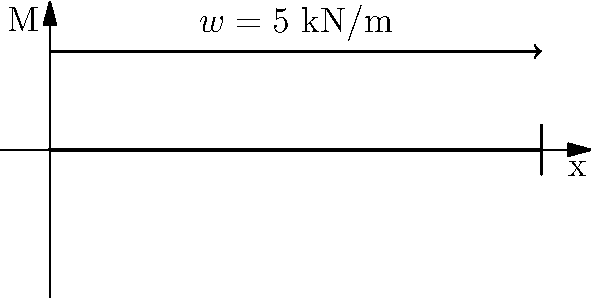A simply supported beam of length 10 m is subjected to a uniformly distributed load of 5 kN/m along its entire length. Calculate the maximum bending moment in the beam and sketch the bending moment diagram. To solve this problem, let's follow these steps:

1) First, we need to calculate the reactions at the supports:
   Total load = $5 \text{ kN/m} \times 10 \text{ m} = 50 \text{ kN}$
   Due to symmetry, each support reaction will be half of this:
   $R_A = R_B = 50 \text{ kN} / 2 = 25 \text{ kN}$

2) The maximum bending moment occurs at the center of the beam. We can calculate this using the formula:
   $M_{max} = \frac{wL^2}{8}$
   Where $w$ is the distributed load and $L$ is the length of the beam.

3) Substituting the values:
   $M_{max} = \frac{5 \text{ kN/m} \times (10 \text{ m})^2}{8} = 62.5 \text{ kN·m}$

4) The bending moment diagram will be parabolic, with zero moment at the supports and maximum moment at the center. The equation of the bending moment at any point $x$ from the left support is:
   $M(x) = \frac{wx}{2}(L-x)$

5) This equation gives us a parabola that starts at zero, reaches a maximum of 62.5 kN·m at the center, and returns to zero at the right support.

The bending moment diagram is shown in the figure, with the maximum bending moment labeled as $M_{max}$.
Answer: $M_{max} = 62.5 \text{ kN·m}$ 